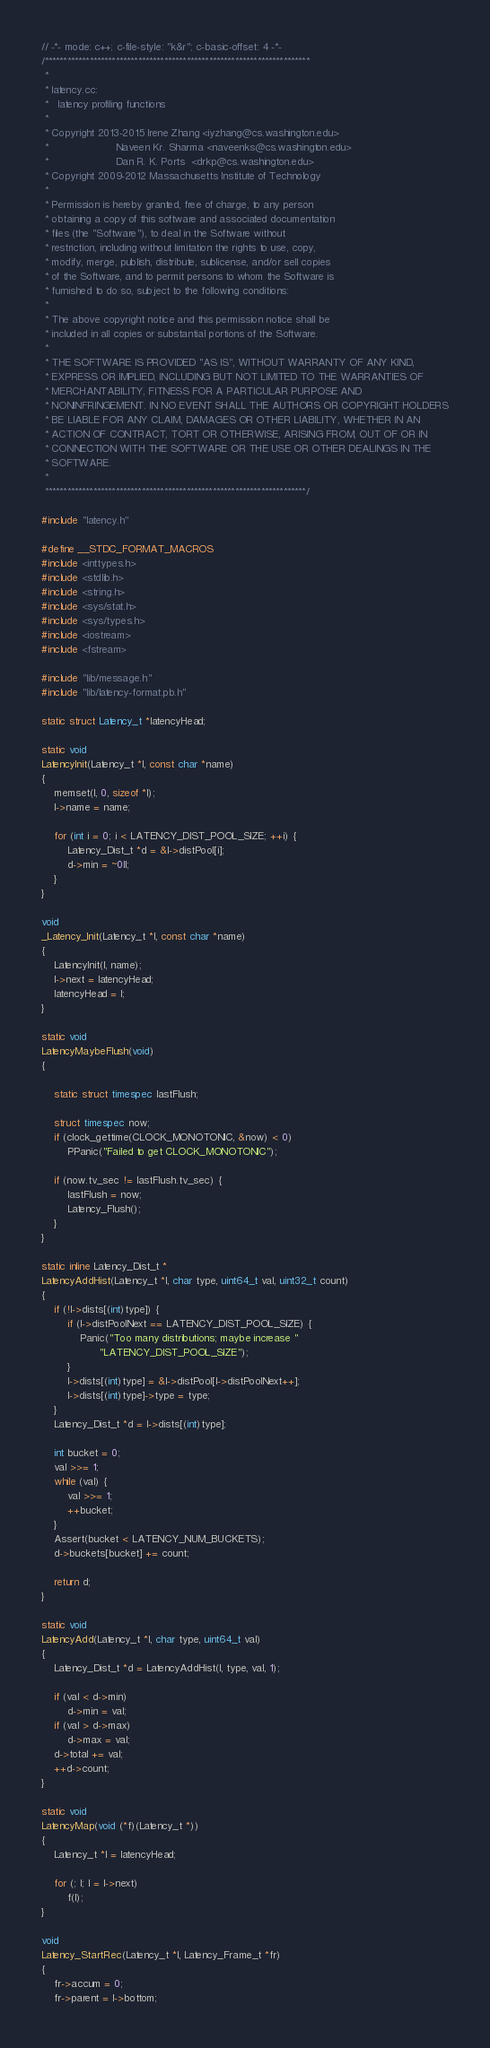Convert code to text. <code><loc_0><loc_0><loc_500><loc_500><_C++_>// -*- mode: c++; c-file-style: "k&r"; c-basic-offset: 4 -*-
/***********************************************************************
 *
 * latency.cc:
 *   latency profiling functions
 *
 * Copyright 2013-2015 Irene Zhang <iyzhang@cs.washington.edu>
 *                     Naveen Kr. Sharma <naveenks@cs.washington.edu>
 *                     Dan R. K. Ports  <drkp@cs.washington.edu>
 * Copyright 2009-2012 Massachusetts Institute of Technology
 *
 * Permission is hereby granted, free of charge, to any person
 * obtaining a copy of this software and associated documentation
 * files (the "Software"), to deal in the Software without
 * restriction, including without limitation the rights to use, copy,
 * modify, merge, publish, distribute, sublicense, and/or sell copies
 * of the Software, and to permit persons to whom the Software is
 * furnished to do so, subject to the following conditions:
 *
 * The above copyright notice and this permission notice shall be
 * included in all copies or substantial portions of the Software.
 *
 * THE SOFTWARE IS PROVIDED "AS IS", WITHOUT WARRANTY OF ANY KIND,
 * EXPRESS OR IMPLIED, INCLUDING BUT NOT LIMITED TO THE WARRANTIES OF
 * MERCHANTABILITY, FITNESS FOR A PARTICULAR PURPOSE AND
 * NONINFRINGEMENT. IN NO EVENT SHALL THE AUTHORS OR COPYRIGHT HOLDERS
 * BE LIABLE FOR ANY CLAIM, DAMAGES OR OTHER LIABILITY, WHETHER IN AN
 * ACTION OF CONTRACT, TORT OR OTHERWISE, ARISING FROM, OUT OF OR IN
 * CONNECTION WITH THE SOFTWARE OR THE USE OR OTHER DEALINGS IN THE
 * SOFTWARE.
 *
 **********************************************************************/

#include "latency.h"

#define __STDC_FORMAT_MACROS
#include <inttypes.h>
#include <stdlib.h>
#include <string.h>
#include <sys/stat.h>
#include <sys/types.h>
#include <iostream>
#include <fstream>

#include "lib/message.h"
#include "lib/latency-format.pb.h"

static struct Latency_t *latencyHead;

static void
LatencyInit(Latency_t *l, const char *name)
{
    memset(l, 0, sizeof *l);
    l->name = name;

    for (int i = 0; i < LATENCY_DIST_POOL_SIZE; ++i) {
        Latency_Dist_t *d = &l->distPool[i];
        d->min = ~0ll;
    }
}

void
_Latency_Init(Latency_t *l, const char *name)
{
    LatencyInit(l, name);
    l->next = latencyHead;
    latencyHead = l;
}

static void
LatencyMaybeFlush(void)
{

    static struct timespec lastFlush;

    struct timespec now;
    if (clock_gettime(CLOCK_MONOTONIC, &now) < 0)
        PPanic("Failed to get CLOCK_MONOTONIC");

    if (now.tv_sec != lastFlush.tv_sec) {
        lastFlush = now;
        Latency_Flush();
    }
}

static inline Latency_Dist_t *
LatencyAddHist(Latency_t *l, char type, uint64_t val, uint32_t count)
{
    if (!l->dists[(int)type]) {
        if (l->distPoolNext == LATENCY_DIST_POOL_SIZE) {
            Panic("Too many distributions; maybe increase "
                  "LATENCY_DIST_POOL_SIZE");
        }
        l->dists[(int)type] = &l->distPool[l->distPoolNext++];
        l->dists[(int)type]->type = type;
    }
    Latency_Dist_t *d = l->dists[(int)type];

    int bucket = 0;
    val >>= 1;
    while (val) {
        val >>= 1;
        ++bucket;
    }
    Assert(bucket < LATENCY_NUM_BUCKETS);
    d->buckets[bucket] += count;

    return d;
}

static void
LatencyAdd(Latency_t *l, char type, uint64_t val)
{
    Latency_Dist_t *d = LatencyAddHist(l, type, val, 1);

    if (val < d->min)
        d->min = val;
    if (val > d->max)
        d->max = val;
    d->total += val;
    ++d->count;
}

static void
LatencyMap(void (*f)(Latency_t *))
{
    Latency_t *l = latencyHead;

    for (; l; l = l->next)
        f(l);
}

void
Latency_StartRec(Latency_t *l, Latency_Frame_t *fr)
{
    fr->accum = 0;
    fr->parent = l->bottom;</code> 